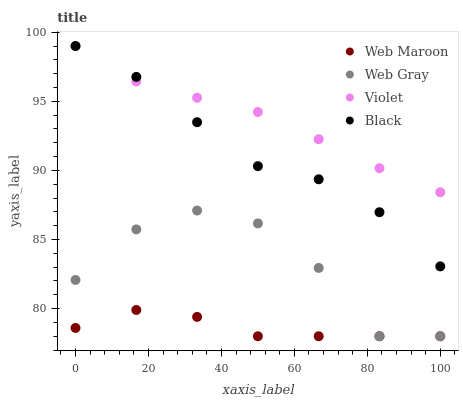Does Web Maroon have the minimum area under the curve?
Answer yes or no. Yes. Does Violet have the maximum area under the curve?
Answer yes or no. Yes. Does Web Gray have the minimum area under the curve?
Answer yes or no. No. Does Web Gray have the maximum area under the curve?
Answer yes or no. No. Is Violet the smoothest?
Answer yes or no. Yes. Is Web Gray the roughest?
Answer yes or no. Yes. Is Web Maroon the smoothest?
Answer yes or no. No. Is Web Maroon the roughest?
Answer yes or no. No. Does Web Gray have the lowest value?
Answer yes or no. Yes. Does Violet have the lowest value?
Answer yes or no. No. Does Violet have the highest value?
Answer yes or no. Yes. Does Web Gray have the highest value?
Answer yes or no. No. Is Web Gray less than Violet?
Answer yes or no. Yes. Is Black greater than Web Gray?
Answer yes or no. Yes. Does Black intersect Violet?
Answer yes or no. Yes. Is Black less than Violet?
Answer yes or no. No. Is Black greater than Violet?
Answer yes or no. No. Does Web Gray intersect Violet?
Answer yes or no. No. 